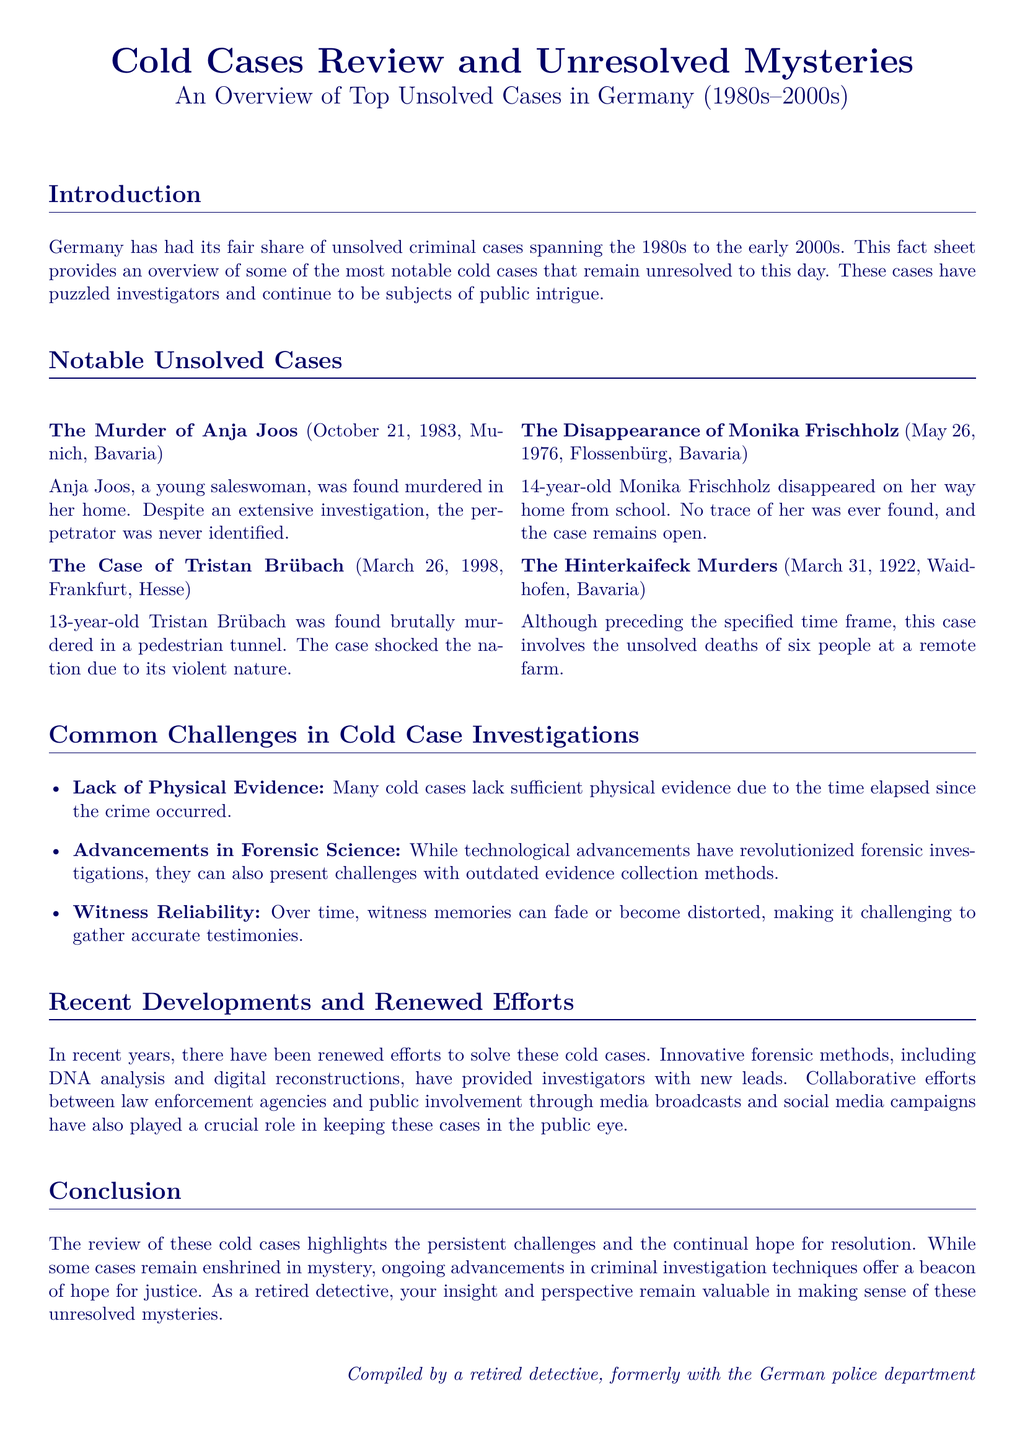What is the name of the young saleswoman murdered in Munich? The case document mentions Anja Joos as the young saleswoman found murdered in Munich.
Answer: Anja Joos What year did Tristan Brübach's murder occur? The document specifies that Tristan Brübach was murdered in March 1998.
Answer: 1998 How old was Monika Frischholz when she disappeared? The document states that Monika Frischholz was 14 years old at the time of her disappearance.
Answer: 14 How many people were involved in the Hinterkaifeck murders? According to the document, six people were killed in the Hinterkaifeck murders.
Answer: Six What is a common challenge mentioned in cold case investigations? The document lists "Lack of Physical Evidence" as a challenge faced in cold case investigations.
Answer: Lack of Physical Evidence What advancements have contributed to solving cold cases recently? The document mentions "DNA analysis and digital reconstructions" as recent advancements aiding investigations.
Answer: DNA analysis and digital reconstructions What initiated public involvement in solving cold cases? The document states that "media broadcasts and social media campaigns" played a crucial role in public involvement.
Answer: Media broadcasts and social media campaigns In which decade does the document primarily focus on unsolved cases? The primary focus of the document on unsolved cases is during the 1980s.
Answer: 1980s 